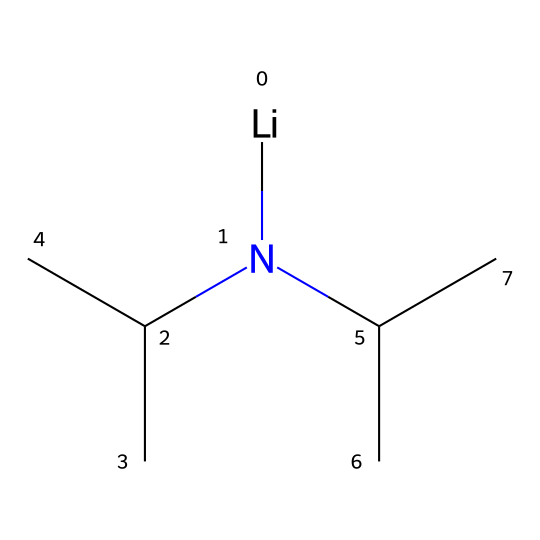What is the molecular formula of lithium diisopropylamide? By looking at the SMILES representation, we can break it down: it has lithium (Li), nitrogen (N), and several carbon (C) and hydrogen (H) atoms from the isopropyl groups. Counting these gives the formula C6H14LiN.
Answer: C6H14LiN How many carbon atoms are present in the molecule? From the SMILES notation, there are six carbon atoms (from the two isopropyl groups). Each isopropyl group contributes three carbons, and there are two of them.
Answer: 6 What type of base is lithium diisopropylamide? LDA is classified as a superbase due to its ability to deprotonate weak acids, which is a characteristic of superbases.
Answer: superbase Which atom in the molecule is responsible for its strong basicity? The nitrogen atom (N) in lithium diisopropylamide is the source of strong basicity as it has a lone pair that can readily deprotonate substrates.
Answer: nitrogen What is the primary functional role of lithium diisopropylamide in organic synthesis? Lithium diisopropylamide primarily acts as a strong base, which facilitates deprotonation reactions in organic synthesis.
Answer: strong base How does the presence of lithium affect the structure of the compound? Lithium serves as a counterion to the nitrogen, stabilizing the anionic character of the protonated nitrogen, which enhances the overall basicity.
Answer: stabilizes What characteristic of the isopropyl groups affects the solubility of lithium diisopropylamide? The isopropyl groups contribute to its nonpolar characteristics, affecting its solubility in organic solvents but making it less soluble in water.
Answer: nonpolar characteristics 